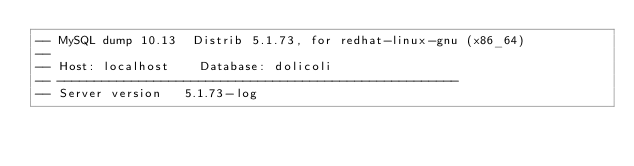<code> <loc_0><loc_0><loc_500><loc_500><_SQL_>-- MySQL dump 10.13  Distrib 5.1.73, for redhat-linux-gnu (x86_64)
--
-- Host: localhost    Database: dolicoli
-- ------------------------------------------------------
-- Server version	5.1.73-log
</code> 